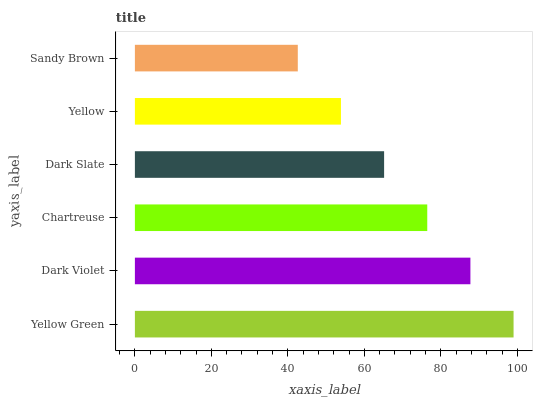Is Sandy Brown the minimum?
Answer yes or no. Yes. Is Yellow Green the maximum?
Answer yes or no. Yes. Is Dark Violet the minimum?
Answer yes or no. No. Is Dark Violet the maximum?
Answer yes or no. No. Is Yellow Green greater than Dark Violet?
Answer yes or no. Yes. Is Dark Violet less than Yellow Green?
Answer yes or no. Yes. Is Dark Violet greater than Yellow Green?
Answer yes or no. No. Is Yellow Green less than Dark Violet?
Answer yes or no. No. Is Chartreuse the high median?
Answer yes or no. Yes. Is Dark Slate the low median?
Answer yes or no. Yes. Is Sandy Brown the high median?
Answer yes or no. No. Is Dark Violet the low median?
Answer yes or no. No. 